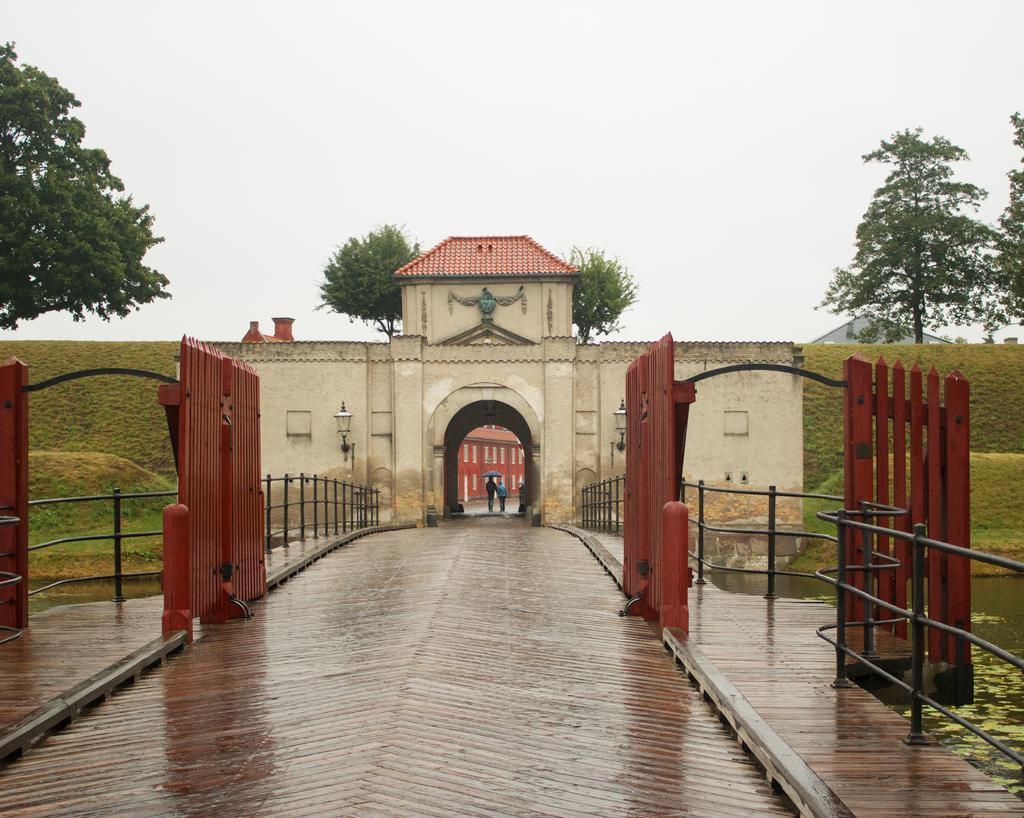Could you give a brief overview of what you see in this image? In this picture there are two persons holding an umbrella and standing near to the building. On the right we can see the fencing and gates. In the background we can see mountain and trees. At the top there is a sky. 